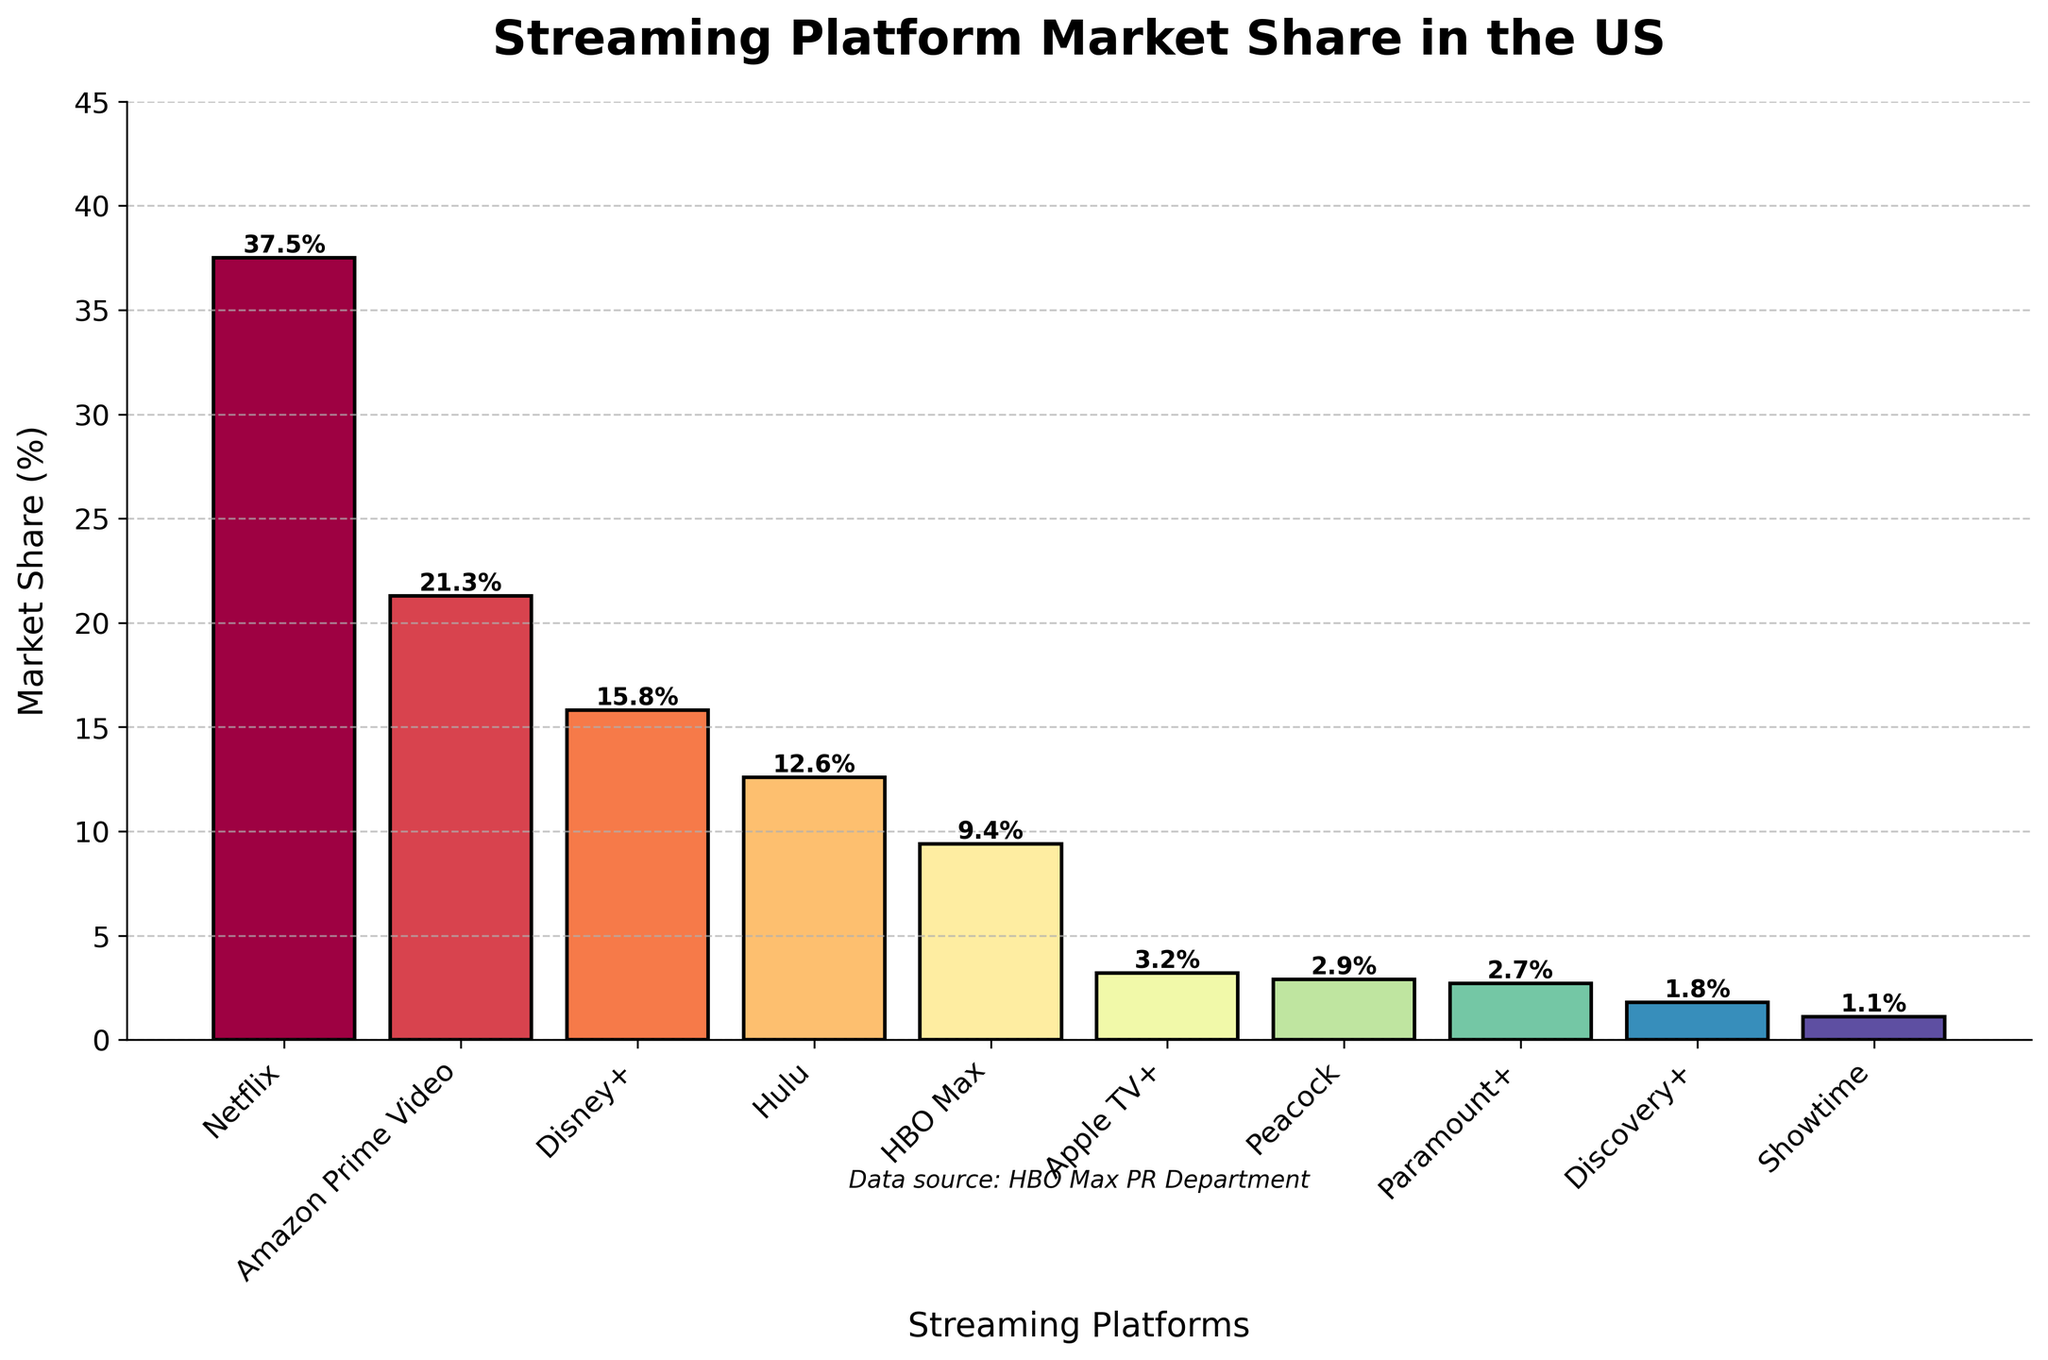Which streaming platform has the highest market share? The highest bar represents the streaming platform with the highest market share. By examining the chart, Netflix has the tallest bar.
Answer: Netflix How does Amazon Prime Video's market share compare to HBO Max's market share? Look at the heights of the bars for Amazon Prime Video and HBO Max. Amazon Prime Video's bar is significantly taller than HBO Max's bar. Additionally, the data labels show Amazon Prime Video has a market share of 21.3%, while HBO Max has 9.4%.
Answer: Amazon Prime Video has a much higher market share than HBO Max What is the combined market share of Disney+, Hulu, and HBO Max? To find the combined market share, add the market shares of Disney+ (15.8%), Hulu (12.6%), and HBO Max (9.4%). So, 15.8 + 12.6 + 9.4 = 37.8%.
Answer: 37.8% Which platform has a lower market share: Peacock or Apple TV+? Compare the heights of the bars for Peacock and Apple TV+. Peacock's bar is shorter than Apple TV+'s bar. The data label shows Peacock at 2.9% and Apple TV+ at 3.2%.
Answer: Peacock What is the difference in market share between the top platform (Netflix) and the lowest platform (Showtime)? Subtract Showtime's market share (1.1%) from Netflix's market share (37.5%). So, 37.5% - 1.1% = 36.4%.
Answer: 36.4% Which platform has the closest market share to HBO Max? Compare the bar heights and numbers near HBO Max's bar. Hulu, with a market share of 12.6%, is next to HBO Max (but a bit higher), indicating it's not the closest. Instead, Discovery+ with 1.8% difference is not as close as Apple TV+ at 3.2%. So Hulu seems close, but closely examined shows it’s not as close as AppleTV+.
Answer: Apple TV+ If you add the market shares of Paramount+ and Discovery+, do they surpass HBO Max's market share? Sum the market shares of Paramount+ (2.7%) and Discovery+ (1.8%), which equals 4.5%. Compare this with HBO Max's market share of 9.4%. Since 4.5% is less than 9.4%, they do not surpass HBO Max.
Answer: No What is the average market share of Showtime, Discovery+, and Paramount+? Sum the market shares of Showtime (1.1%), Discovery+ (1.8%), and Paramount+ (2.7%) and then divide by 3. So, (1.1 + 1.8 + 2.7) / 3 = 1.8667%.
Answer: 1.87% Identify the streaming platform with the least market share and provide its value. The shortest bar on the chart belongs to Showtime. The data label on it states that Showtime's market share is 1.1%.
Answer: Showtime, 1.1% 